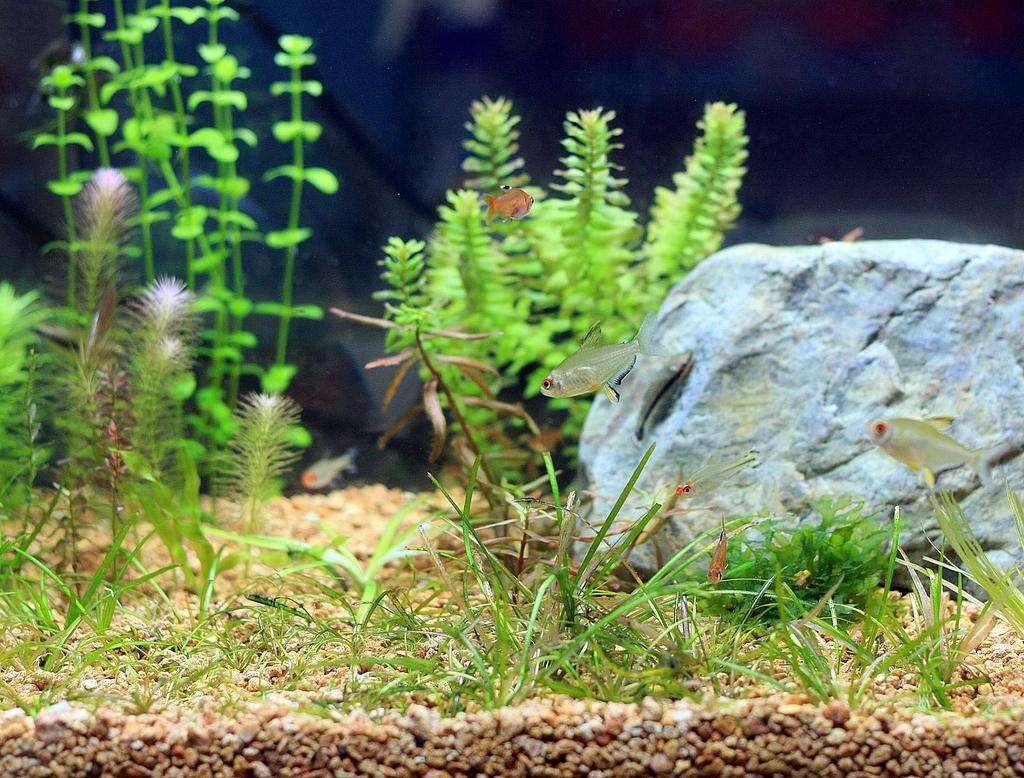Could you give a brief overview of what you see in this image? There is a stone in the image. There are fishes. There is grass and water plants. At the bottom of the image there are stones. 